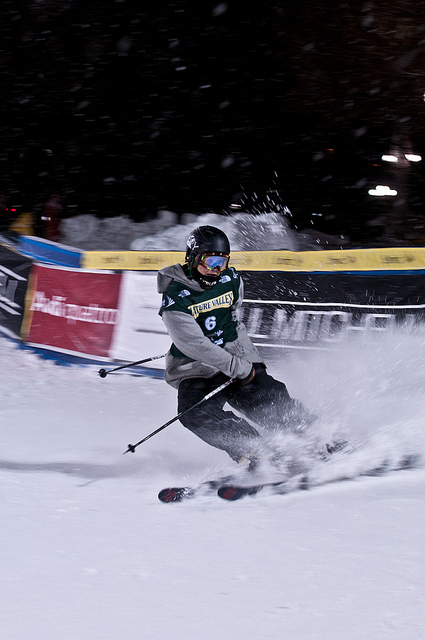Please transcribe the text in this image. 6 